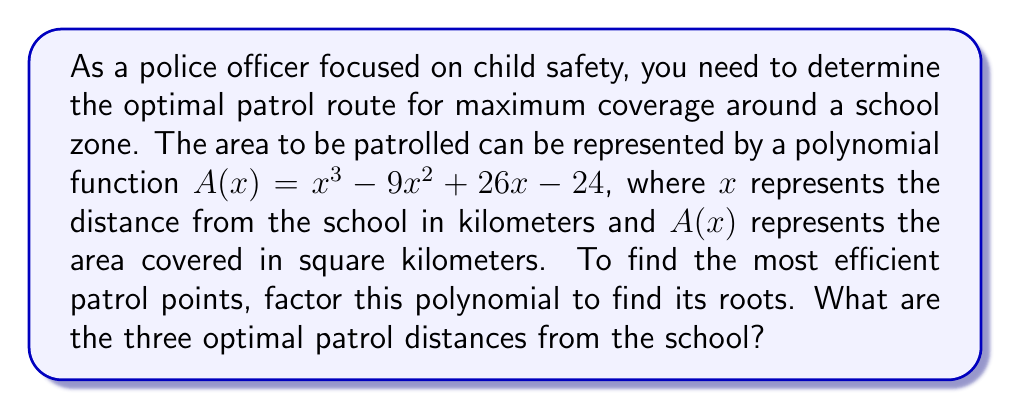Could you help me with this problem? To solve this problem, we need to factor the polynomial $A(x) = x^3 - 9x^2 + 26x - 24$. We can use the following steps:

1) First, let's check if there's a common factor:
   There is no common factor for all terms.

2) Next, we can try the rational root theorem. The possible rational roots are the factors of the constant term (24): ±1, ±2, ±3, ±4, ±6, ±8, ±12, ±24.

3) By testing these values, we find that $x = 2$ is a root of the polynomial.

4) We can factor out $(x - 2)$:
   $A(x) = (x - 2)(x^2 - 7x + 12)$

5) The quadratic factor $x^2 - 7x + 12$ can be factored further:
   $x^2 - 7x + 12 = (x - 3)(x - 4)$

6) Therefore, the fully factored polynomial is:
   $A(x) = (x - 2)(x - 3)(x - 4)$

7) The roots of this polynomial are $x = 2$, $x = 3$, and $x = 4$.

These roots represent the optimal patrol distances from the school in kilometers, as they are the points where the area coverage function equals zero, indicating the boundaries of the patrol area.
Answer: The three optimal patrol distances from the school are 2 km, 3 km, and 4 km. 